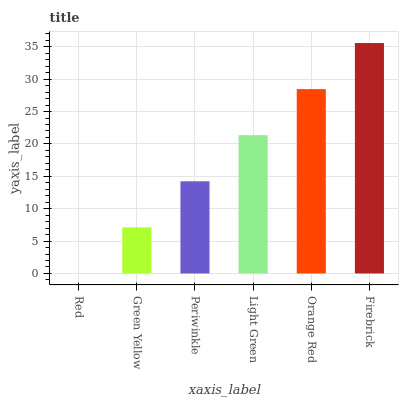Is Red the minimum?
Answer yes or no. Yes. Is Firebrick the maximum?
Answer yes or no. Yes. Is Green Yellow the minimum?
Answer yes or no. No. Is Green Yellow the maximum?
Answer yes or no. No. Is Green Yellow greater than Red?
Answer yes or no. Yes. Is Red less than Green Yellow?
Answer yes or no. Yes. Is Red greater than Green Yellow?
Answer yes or no. No. Is Green Yellow less than Red?
Answer yes or no. No. Is Light Green the high median?
Answer yes or no. Yes. Is Periwinkle the low median?
Answer yes or no. Yes. Is Periwinkle the high median?
Answer yes or no. No. Is Red the low median?
Answer yes or no. No. 